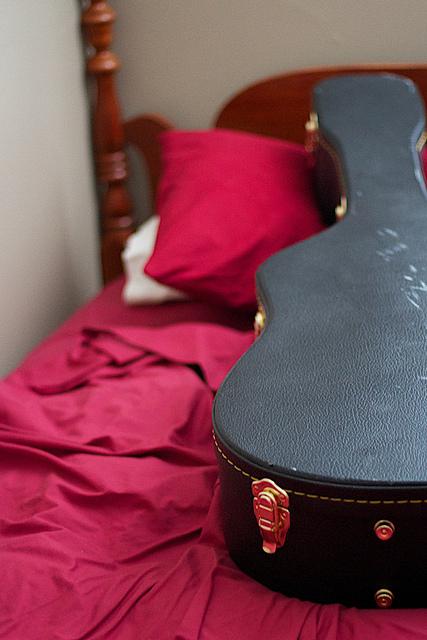Where are the pillows?
Answer briefly. On bed. What is the bed made out of?
Give a very brief answer. Wood. Is that a guitar on the bed?
Answer briefly. Yes. 